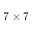<formula> <loc_0><loc_0><loc_500><loc_500>7 \times 7</formula> 